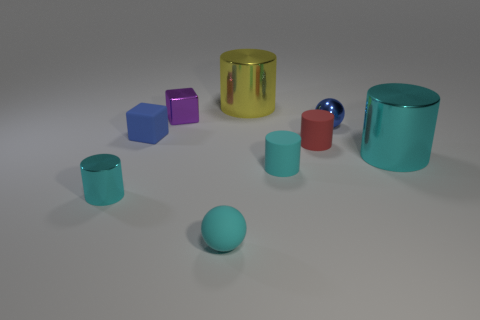What number of other metal spheres have the same color as the metallic ball?
Offer a terse response. 0. How many objects are either shiny objects that are on the left side of the red matte cylinder or shiny cylinders in front of the blue sphere?
Your answer should be compact. 4. There is a blue object to the right of the tiny blue rubber cube; what number of small metal balls are behind it?
Provide a short and direct response. 0. What color is the tiny cylinder that is the same material as the tiny purple cube?
Make the answer very short. Cyan. Are there any other cyan spheres of the same size as the rubber sphere?
Give a very brief answer. No. The blue object that is the same size as the metal ball is what shape?
Your answer should be compact. Cube. Is there another small red object that has the same shape as the small red thing?
Your answer should be very brief. No. Are the tiny purple block and the large object in front of the purple block made of the same material?
Offer a terse response. Yes. Are there any other small rubber cubes of the same color as the tiny matte cube?
Provide a short and direct response. No. What number of other things are made of the same material as the yellow cylinder?
Your response must be concise. 4. 